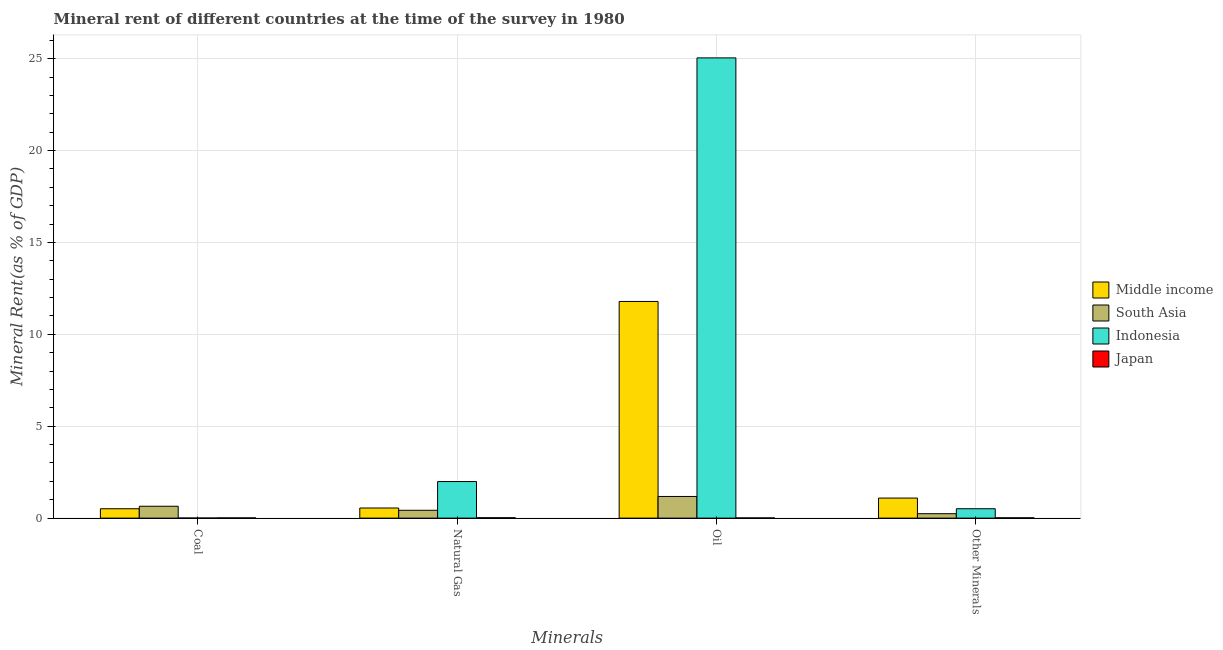How many groups of bars are there?
Your answer should be very brief. 4. Are the number of bars on each tick of the X-axis equal?
Give a very brief answer. Yes. How many bars are there on the 4th tick from the left?
Provide a succinct answer. 4. What is the label of the 1st group of bars from the left?
Give a very brief answer. Coal. What is the oil rent in Middle income?
Provide a short and direct response. 11.79. Across all countries, what is the maximum  rent of other minerals?
Keep it short and to the point. 1.09. Across all countries, what is the minimum oil rent?
Your answer should be very brief. 0.01. In which country was the coal rent minimum?
Offer a terse response. Indonesia. What is the total oil rent in the graph?
Offer a very short reply. 38.03. What is the difference between the coal rent in Indonesia and that in Japan?
Your response must be concise. -0.01. What is the difference between the natural gas rent in South Asia and the  rent of other minerals in Indonesia?
Give a very brief answer. -0.08. What is the average oil rent per country?
Your answer should be very brief. 9.51. What is the difference between the coal rent and oil rent in Japan?
Make the answer very short. 0. What is the ratio of the  rent of other minerals in South Asia to that in Middle income?
Give a very brief answer. 0.22. Is the coal rent in South Asia less than that in Japan?
Give a very brief answer. No. What is the difference between the highest and the second highest  rent of other minerals?
Make the answer very short. 0.58. What is the difference between the highest and the lowest natural gas rent?
Make the answer very short. 1.97. Is the sum of the coal rent in South Asia and Middle income greater than the maximum  rent of other minerals across all countries?
Make the answer very short. Yes. Is it the case that in every country, the sum of the coal rent and oil rent is greater than the sum of natural gas rent and  rent of other minerals?
Your response must be concise. No. What does the 2nd bar from the right in Other Minerals represents?
Your answer should be very brief. Indonesia. What is the difference between two consecutive major ticks on the Y-axis?
Your answer should be compact. 5. Are the values on the major ticks of Y-axis written in scientific E-notation?
Provide a succinct answer. No. Where does the legend appear in the graph?
Your response must be concise. Center right. What is the title of the graph?
Give a very brief answer. Mineral rent of different countries at the time of the survey in 1980. What is the label or title of the X-axis?
Your answer should be very brief. Minerals. What is the label or title of the Y-axis?
Your response must be concise. Mineral Rent(as % of GDP). What is the Mineral Rent(as % of GDP) of Middle income in Coal?
Provide a short and direct response. 0.51. What is the Mineral Rent(as % of GDP) of South Asia in Coal?
Provide a succinct answer. 0.65. What is the Mineral Rent(as % of GDP) of Indonesia in Coal?
Keep it short and to the point. 0. What is the Mineral Rent(as % of GDP) of Japan in Coal?
Provide a succinct answer. 0.01. What is the Mineral Rent(as % of GDP) of Middle income in Natural Gas?
Ensure brevity in your answer.  0.55. What is the Mineral Rent(as % of GDP) of South Asia in Natural Gas?
Your answer should be compact. 0.43. What is the Mineral Rent(as % of GDP) of Indonesia in Natural Gas?
Your answer should be compact. 1.99. What is the Mineral Rent(as % of GDP) in Japan in Natural Gas?
Give a very brief answer. 0.02. What is the Mineral Rent(as % of GDP) in Middle income in Oil?
Keep it short and to the point. 11.79. What is the Mineral Rent(as % of GDP) of South Asia in Oil?
Give a very brief answer. 1.18. What is the Mineral Rent(as % of GDP) in Indonesia in Oil?
Your answer should be compact. 25.05. What is the Mineral Rent(as % of GDP) in Japan in Oil?
Provide a short and direct response. 0.01. What is the Mineral Rent(as % of GDP) in Middle income in Other Minerals?
Ensure brevity in your answer.  1.09. What is the Mineral Rent(as % of GDP) of South Asia in Other Minerals?
Your answer should be very brief. 0.24. What is the Mineral Rent(as % of GDP) in Indonesia in Other Minerals?
Your answer should be very brief. 0.51. What is the Mineral Rent(as % of GDP) in Japan in Other Minerals?
Give a very brief answer. 0.02. Across all Minerals, what is the maximum Mineral Rent(as % of GDP) in Middle income?
Offer a terse response. 11.79. Across all Minerals, what is the maximum Mineral Rent(as % of GDP) of South Asia?
Your answer should be very brief. 1.18. Across all Minerals, what is the maximum Mineral Rent(as % of GDP) of Indonesia?
Your answer should be compact. 25.05. Across all Minerals, what is the maximum Mineral Rent(as % of GDP) in Japan?
Ensure brevity in your answer.  0.02. Across all Minerals, what is the minimum Mineral Rent(as % of GDP) in Middle income?
Provide a succinct answer. 0.51. Across all Minerals, what is the minimum Mineral Rent(as % of GDP) of South Asia?
Your response must be concise. 0.24. Across all Minerals, what is the minimum Mineral Rent(as % of GDP) in Indonesia?
Make the answer very short. 0. Across all Minerals, what is the minimum Mineral Rent(as % of GDP) in Japan?
Your answer should be compact. 0.01. What is the total Mineral Rent(as % of GDP) of Middle income in the graph?
Keep it short and to the point. 13.94. What is the total Mineral Rent(as % of GDP) of South Asia in the graph?
Your answer should be compact. 2.49. What is the total Mineral Rent(as % of GDP) in Indonesia in the graph?
Give a very brief answer. 27.55. What is the total Mineral Rent(as % of GDP) in Japan in the graph?
Ensure brevity in your answer.  0.06. What is the difference between the Mineral Rent(as % of GDP) of Middle income in Coal and that in Natural Gas?
Your answer should be compact. -0.04. What is the difference between the Mineral Rent(as % of GDP) in South Asia in Coal and that in Natural Gas?
Provide a succinct answer. 0.22. What is the difference between the Mineral Rent(as % of GDP) of Indonesia in Coal and that in Natural Gas?
Offer a very short reply. -1.99. What is the difference between the Mineral Rent(as % of GDP) in Japan in Coal and that in Natural Gas?
Your answer should be compact. -0.01. What is the difference between the Mineral Rent(as % of GDP) of Middle income in Coal and that in Oil?
Provide a succinct answer. -11.28. What is the difference between the Mineral Rent(as % of GDP) of South Asia in Coal and that in Oil?
Your answer should be compact. -0.53. What is the difference between the Mineral Rent(as % of GDP) of Indonesia in Coal and that in Oil?
Ensure brevity in your answer.  -25.04. What is the difference between the Mineral Rent(as % of GDP) of Japan in Coal and that in Oil?
Offer a very short reply. 0. What is the difference between the Mineral Rent(as % of GDP) in Middle income in Coal and that in Other Minerals?
Ensure brevity in your answer.  -0.58. What is the difference between the Mineral Rent(as % of GDP) in South Asia in Coal and that in Other Minerals?
Ensure brevity in your answer.  0.41. What is the difference between the Mineral Rent(as % of GDP) in Indonesia in Coal and that in Other Minerals?
Ensure brevity in your answer.  -0.51. What is the difference between the Mineral Rent(as % of GDP) of Japan in Coal and that in Other Minerals?
Your answer should be compact. -0. What is the difference between the Mineral Rent(as % of GDP) in Middle income in Natural Gas and that in Oil?
Make the answer very short. -11.24. What is the difference between the Mineral Rent(as % of GDP) of South Asia in Natural Gas and that in Oil?
Provide a short and direct response. -0.75. What is the difference between the Mineral Rent(as % of GDP) of Indonesia in Natural Gas and that in Oil?
Provide a succinct answer. -23.06. What is the difference between the Mineral Rent(as % of GDP) of Japan in Natural Gas and that in Oil?
Give a very brief answer. 0.01. What is the difference between the Mineral Rent(as % of GDP) of Middle income in Natural Gas and that in Other Minerals?
Keep it short and to the point. -0.54. What is the difference between the Mineral Rent(as % of GDP) in South Asia in Natural Gas and that in Other Minerals?
Provide a succinct answer. 0.19. What is the difference between the Mineral Rent(as % of GDP) in Indonesia in Natural Gas and that in Other Minerals?
Make the answer very short. 1.48. What is the difference between the Mineral Rent(as % of GDP) in Japan in Natural Gas and that in Other Minerals?
Your answer should be very brief. 0. What is the difference between the Mineral Rent(as % of GDP) of Middle income in Oil and that in Other Minerals?
Your response must be concise. 10.7. What is the difference between the Mineral Rent(as % of GDP) in South Asia in Oil and that in Other Minerals?
Provide a succinct answer. 0.94. What is the difference between the Mineral Rent(as % of GDP) of Indonesia in Oil and that in Other Minerals?
Give a very brief answer. 24.54. What is the difference between the Mineral Rent(as % of GDP) in Japan in Oil and that in Other Minerals?
Your response must be concise. -0.01. What is the difference between the Mineral Rent(as % of GDP) of Middle income in Coal and the Mineral Rent(as % of GDP) of South Asia in Natural Gas?
Your answer should be very brief. 0.08. What is the difference between the Mineral Rent(as % of GDP) of Middle income in Coal and the Mineral Rent(as % of GDP) of Indonesia in Natural Gas?
Provide a short and direct response. -1.48. What is the difference between the Mineral Rent(as % of GDP) of Middle income in Coal and the Mineral Rent(as % of GDP) of Japan in Natural Gas?
Offer a terse response. 0.49. What is the difference between the Mineral Rent(as % of GDP) of South Asia in Coal and the Mineral Rent(as % of GDP) of Indonesia in Natural Gas?
Provide a short and direct response. -1.34. What is the difference between the Mineral Rent(as % of GDP) of South Asia in Coal and the Mineral Rent(as % of GDP) of Japan in Natural Gas?
Your response must be concise. 0.63. What is the difference between the Mineral Rent(as % of GDP) of Indonesia in Coal and the Mineral Rent(as % of GDP) of Japan in Natural Gas?
Offer a terse response. -0.02. What is the difference between the Mineral Rent(as % of GDP) of Middle income in Coal and the Mineral Rent(as % of GDP) of South Asia in Oil?
Your response must be concise. -0.67. What is the difference between the Mineral Rent(as % of GDP) in Middle income in Coal and the Mineral Rent(as % of GDP) in Indonesia in Oil?
Make the answer very short. -24.54. What is the difference between the Mineral Rent(as % of GDP) in Middle income in Coal and the Mineral Rent(as % of GDP) in Japan in Oil?
Provide a succinct answer. 0.5. What is the difference between the Mineral Rent(as % of GDP) of South Asia in Coal and the Mineral Rent(as % of GDP) of Indonesia in Oil?
Offer a terse response. -24.4. What is the difference between the Mineral Rent(as % of GDP) of South Asia in Coal and the Mineral Rent(as % of GDP) of Japan in Oil?
Keep it short and to the point. 0.64. What is the difference between the Mineral Rent(as % of GDP) of Indonesia in Coal and the Mineral Rent(as % of GDP) of Japan in Oil?
Give a very brief answer. -0.01. What is the difference between the Mineral Rent(as % of GDP) of Middle income in Coal and the Mineral Rent(as % of GDP) of South Asia in Other Minerals?
Your response must be concise. 0.27. What is the difference between the Mineral Rent(as % of GDP) in Middle income in Coal and the Mineral Rent(as % of GDP) in Indonesia in Other Minerals?
Ensure brevity in your answer.  -0. What is the difference between the Mineral Rent(as % of GDP) of Middle income in Coal and the Mineral Rent(as % of GDP) of Japan in Other Minerals?
Offer a terse response. 0.49. What is the difference between the Mineral Rent(as % of GDP) of South Asia in Coal and the Mineral Rent(as % of GDP) of Indonesia in Other Minerals?
Make the answer very short. 0.14. What is the difference between the Mineral Rent(as % of GDP) in South Asia in Coal and the Mineral Rent(as % of GDP) in Japan in Other Minerals?
Your response must be concise. 0.63. What is the difference between the Mineral Rent(as % of GDP) in Indonesia in Coal and the Mineral Rent(as % of GDP) in Japan in Other Minerals?
Offer a terse response. -0.01. What is the difference between the Mineral Rent(as % of GDP) in Middle income in Natural Gas and the Mineral Rent(as % of GDP) in South Asia in Oil?
Provide a short and direct response. -0.63. What is the difference between the Mineral Rent(as % of GDP) in Middle income in Natural Gas and the Mineral Rent(as % of GDP) in Indonesia in Oil?
Give a very brief answer. -24.5. What is the difference between the Mineral Rent(as % of GDP) in Middle income in Natural Gas and the Mineral Rent(as % of GDP) in Japan in Oil?
Make the answer very short. 0.54. What is the difference between the Mineral Rent(as % of GDP) in South Asia in Natural Gas and the Mineral Rent(as % of GDP) in Indonesia in Oil?
Your answer should be very brief. -24.62. What is the difference between the Mineral Rent(as % of GDP) in South Asia in Natural Gas and the Mineral Rent(as % of GDP) in Japan in Oil?
Your answer should be very brief. 0.42. What is the difference between the Mineral Rent(as % of GDP) in Indonesia in Natural Gas and the Mineral Rent(as % of GDP) in Japan in Oil?
Your answer should be very brief. 1.98. What is the difference between the Mineral Rent(as % of GDP) of Middle income in Natural Gas and the Mineral Rent(as % of GDP) of South Asia in Other Minerals?
Your response must be concise. 0.31. What is the difference between the Mineral Rent(as % of GDP) of Middle income in Natural Gas and the Mineral Rent(as % of GDP) of Indonesia in Other Minerals?
Ensure brevity in your answer.  0.04. What is the difference between the Mineral Rent(as % of GDP) of Middle income in Natural Gas and the Mineral Rent(as % of GDP) of Japan in Other Minerals?
Provide a short and direct response. 0.53. What is the difference between the Mineral Rent(as % of GDP) of South Asia in Natural Gas and the Mineral Rent(as % of GDP) of Indonesia in Other Minerals?
Make the answer very short. -0.08. What is the difference between the Mineral Rent(as % of GDP) in South Asia in Natural Gas and the Mineral Rent(as % of GDP) in Japan in Other Minerals?
Offer a very short reply. 0.41. What is the difference between the Mineral Rent(as % of GDP) in Indonesia in Natural Gas and the Mineral Rent(as % of GDP) in Japan in Other Minerals?
Your answer should be compact. 1.97. What is the difference between the Mineral Rent(as % of GDP) of Middle income in Oil and the Mineral Rent(as % of GDP) of South Asia in Other Minerals?
Give a very brief answer. 11.55. What is the difference between the Mineral Rent(as % of GDP) in Middle income in Oil and the Mineral Rent(as % of GDP) in Indonesia in Other Minerals?
Give a very brief answer. 11.28. What is the difference between the Mineral Rent(as % of GDP) of Middle income in Oil and the Mineral Rent(as % of GDP) of Japan in Other Minerals?
Give a very brief answer. 11.78. What is the difference between the Mineral Rent(as % of GDP) of South Asia in Oil and the Mineral Rent(as % of GDP) of Indonesia in Other Minerals?
Offer a terse response. 0.67. What is the difference between the Mineral Rent(as % of GDP) of South Asia in Oil and the Mineral Rent(as % of GDP) of Japan in Other Minerals?
Your answer should be very brief. 1.16. What is the difference between the Mineral Rent(as % of GDP) in Indonesia in Oil and the Mineral Rent(as % of GDP) in Japan in Other Minerals?
Your answer should be very brief. 25.03. What is the average Mineral Rent(as % of GDP) in Middle income per Minerals?
Provide a short and direct response. 3.49. What is the average Mineral Rent(as % of GDP) in South Asia per Minerals?
Keep it short and to the point. 0.62. What is the average Mineral Rent(as % of GDP) of Indonesia per Minerals?
Ensure brevity in your answer.  6.89. What is the average Mineral Rent(as % of GDP) of Japan per Minerals?
Offer a very short reply. 0.01. What is the difference between the Mineral Rent(as % of GDP) of Middle income and Mineral Rent(as % of GDP) of South Asia in Coal?
Provide a succinct answer. -0.14. What is the difference between the Mineral Rent(as % of GDP) of Middle income and Mineral Rent(as % of GDP) of Indonesia in Coal?
Your response must be concise. 0.51. What is the difference between the Mineral Rent(as % of GDP) of Middle income and Mineral Rent(as % of GDP) of Japan in Coal?
Offer a terse response. 0.5. What is the difference between the Mineral Rent(as % of GDP) of South Asia and Mineral Rent(as % of GDP) of Indonesia in Coal?
Keep it short and to the point. 0.64. What is the difference between the Mineral Rent(as % of GDP) in South Asia and Mineral Rent(as % of GDP) in Japan in Coal?
Offer a very short reply. 0.63. What is the difference between the Mineral Rent(as % of GDP) of Indonesia and Mineral Rent(as % of GDP) of Japan in Coal?
Ensure brevity in your answer.  -0.01. What is the difference between the Mineral Rent(as % of GDP) in Middle income and Mineral Rent(as % of GDP) in South Asia in Natural Gas?
Your answer should be very brief. 0.12. What is the difference between the Mineral Rent(as % of GDP) of Middle income and Mineral Rent(as % of GDP) of Indonesia in Natural Gas?
Offer a very short reply. -1.44. What is the difference between the Mineral Rent(as % of GDP) in Middle income and Mineral Rent(as % of GDP) in Japan in Natural Gas?
Keep it short and to the point. 0.53. What is the difference between the Mineral Rent(as % of GDP) in South Asia and Mineral Rent(as % of GDP) in Indonesia in Natural Gas?
Offer a terse response. -1.56. What is the difference between the Mineral Rent(as % of GDP) of South Asia and Mineral Rent(as % of GDP) of Japan in Natural Gas?
Your response must be concise. 0.41. What is the difference between the Mineral Rent(as % of GDP) in Indonesia and Mineral Rent(as % of GDP) in Japan in Natural Gas?
Make the answer very short. 1.97. What is the difference between the Mineral Rent(as % of GDP) of Middle income and Mineral Rent(as % of GDP) of South Asia in Oil?
Provide a short and direct response. 10.61. What is the difference between the Mineral Rent(as % of GDP) in Middle income and Mineral Rent(as % of GDP) in Indonesia in Oil?
Make the answer very short. -13.26. What is the difference between the Mineral Rent(as % of GDP) in Middle income and Mineral Rent(as % of GDP) in Japan in Oil?
Provide a short and direct response. 11.78. What is the difference between the Mineral Rent(as % of GDP) in South Asia and Mineral Rent(as % of GDP) in Indonesia in Oil?
Your answer should be compact. -23.87. What is the difference between the Mineral Rent(as % of GDP) of South Asia and Mineral Rent(as % of GDP) of Japan in Oil?
Your answer should be very brief. 1.17. What is the difference between the Mineral Rent(as % of GDP) in Indonesia and Mineral Rent(as % of GDP) in Japan in Oil?
Make the answer very short. 25.04. What is the difference between the Mineral Rent(as % of GDP) of Middle income and Mineral Rent(as % of GDP) of South Asia in Other Minerals?
Your response must be concise. 0.85. What is the difference between the Mineral Rent(as % of GDP) of Middle income and Mineral Rent(as % of GDP) of Indonesia in Other Minerals?
Give a very brief answer. 0.58. What is the difference between the Mineral Rent(as % of GDP) of Middle income and Mineral Rent(as % of GDP) of Japan in Other Minerals?
Offer a very short reply. 1.08. What is the difference between the Mineral Rent(as % of GDP) in South Asia and Mineral Rent(as % of GDP) in Indonesia in Other Minerals?
Your answer should be compact. -0.27. What is the difference between the Mineral Rent(as % of GDP) in South Asia and Mineral Rent(as % of GDP) in Japan in Other Minerals?
Offer a very short reply. 0.22. What is the difference between the Mineral Rent(as % of GDP) of Indonesia and Mineral Rent(as % of GDP) of Japan in Other Minerals?
Your response must be concise. 0.49. What is the ratio of the Mineral Rent(as % of GDP) of Middle income in Coal to that in Natural Gas?
Offer a very short reply. 0.93. What is the ratio of the Mineral Rent(as % of GDP) in South Asia in Coal to that in Natural Gas?
Your answer should be compact. 1.51. What is the ratio of the Mineral Rent(as % of GDP) in Indonesia in Coal to that in Natural Gas?
Your answer should be very brief. 0. What is the ratio of the Mineral Rent(as % of GDP) in Japan in Coal to that in Natural Gas?
Keep it short and to the point. 0.56. What is the ratio of the Mineral Rent(as % of GDP) of Middle income in Coal to that in Oil?
Your answer should be very brief. 0.04. What is the ratio of the Mineral Rent(as % of GDP) of South Asia in Coal to that in Oil?
Provide a succinct answer. 0.55. What is the ratio of the Mineral Rent(as % of GDP) of Japan in Coal to that in Oil?
Your answer should be compact. 1.11. What is the ratio of the Mineral Rent(as % of GDP) of Middle income in Coal to that in Other Minerals?
Offer a terse response. 0.47. What is the ratio of the Mineral Rent(as % of GDP) in South Asia in Coal to that in Other Minerals?
Keep it short and to the point. 2.69. What is the ratio of the Mineral Rent(as % of GDP) of Indonesia in Coal to that in Other Minerals?
Offer a terse response. 0.01. What is the ratio of the Mineral Rent(as % of GDP) in Japan in Coal to that in Other Minerals?
Make the answer very short. 0.72. What is the ratio of the Mineral Rent(as % of GDP) in Middle income in Natural Gas to that in Oil?
Keep it short and to the point. 0.05. What is the ratio of the Mineral Rent(as % of GDP) in South Asia in Natural Gas to that in Oil?
Ensure brevity in your answer.  0.36. What is the ratio of the Mineral Rent(as % of GDP) in Indonesia in Natural Gas to that in Oil?
Make the answer very short. 0.08. What is the ratio of the Mineral Rent(as % of GDP) of Japan in Natural Gas to that in Oil?
Your response must be concise. 1.99. What is the ratio of the Mineral Rent(as % of GDP) of Middle income in Natural Gas to that in Other Minerals?
Your answer should be very brief. 0.5. What is the ratio of the Mineral Rent(as % of GDP) in South Asia in Natural Gas to that in Other Minerals?
Ensure brevity in your answer.  1.78. What is the ratio of the Mineral Rent(as % of GDP) of Indonesia in Natural Gas to that in Other Minerals?
Offer a terse response. 3.9. What is the ratio of the Mineral Rent(as % of GDP) in Japan in Natural Gas to that in Other Minerals?
Give a very brief answer. 1.28. What is the ratio of the Mineral Rent(as % of GDP) in Middle income in Oil to that in Other Minerals?
Make the answer very short. 10.8. What is the ratio of the Mineral Rent(as % of GDP) of South Asia in Oil to that in Other Minerals?
Offer a terse response. 4.9. What is the ratio of the Mineral Rent(as % of GDP) of Indonesia in Oil to that in Other Minerals?
Your response must be concise. 49.03. What is the ratio of the Mineral Rent(as % of GDP) in Japan in Oil to that in Other Minerals?
Ensure brevity in your answer.  0.64. What is the difference between the highest and the second highest Mineral Rent(as % of GDP) in Middle income?
Your response must be concise. 10.7. What is the difference between the highest and the second highest Mineral Rent(as % of GDP) in South Asia?
Your answer should be very brief. 0.53. What is the difference between the highest and the second highest Mineral Rent(as % of GDP) in Indonesia?
Keep it short and to the point. 23.06. What is the difference between the highest and the second highest Mineral Rent(as % of GDP) of Japan?
Offer a terse response. 0. What is the difference between the highest and the lowest Mineral Rent(as % of GDP) in Middle income?
Ensure brevity in your answer.  11.28. What is the difference between the highest and the lowest Mineral Rent(as % of GDP) in South Asia?
Your answer should be compact. 0.94. What is the difference between the highest and the lowest Mineral Rent(as % of GDP) of Indonesia?
Provide a succinct answer. 25.04. What is the difference between the highest and the lowest Mineral Rent(as % of GDP) of Japan?
Your answer should be compact. 0.01. 